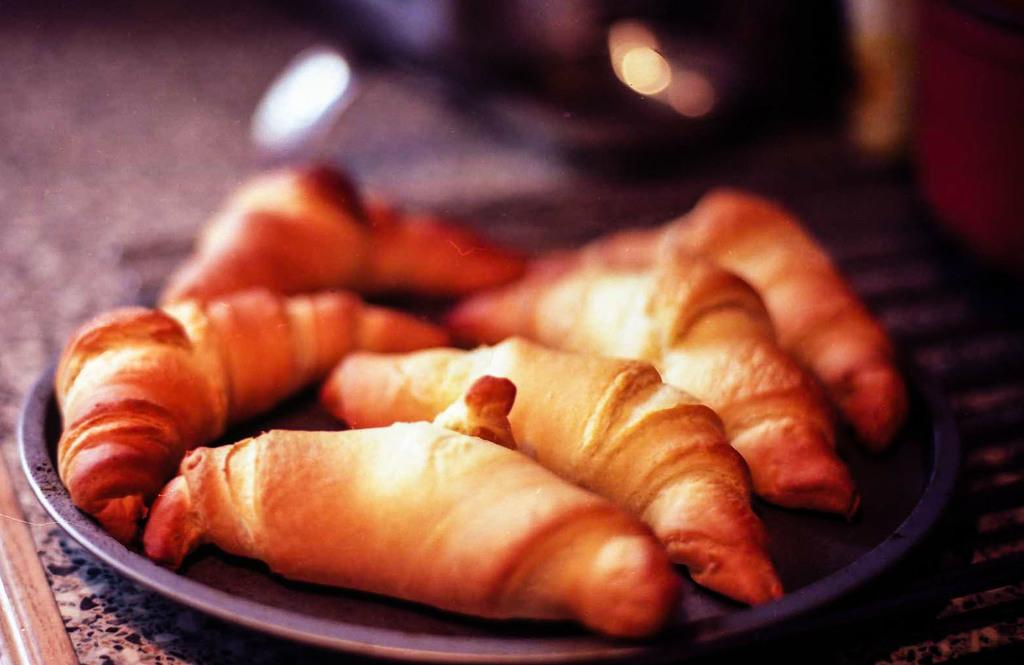What is the main piece of furniture in the image? There is a table in the image. What can be found on the table in the image? There are food items on a plate in the image. Can you describe the background of the image? The background of the image contains some unclear elements. What type of pan is being used to cook the toys in the image? There are no toys or pans present in the image. 